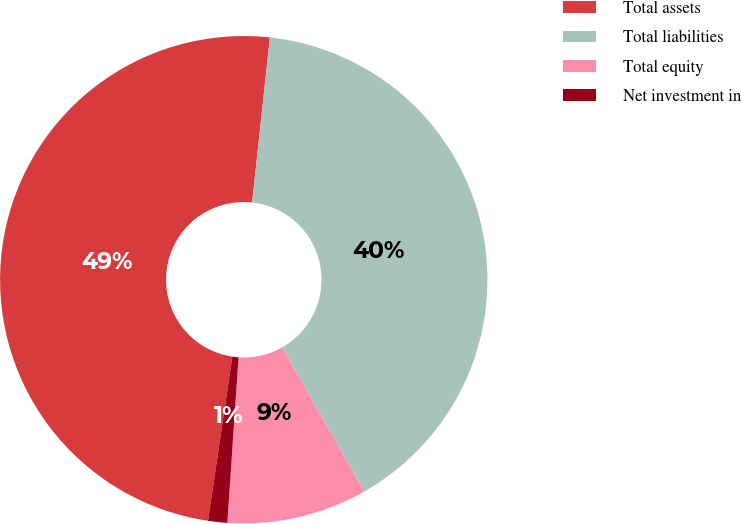Convert chart. <chart><loc_0><loc_0><loc_500><loc_500><pie_chart><fcel>Total assets<fcel>Total liabilities<fcel>Total equity<fcel>Net investment in<nl><fcel>49.36%<fcel>40.05%<fcel>9.31%<fcel>1.27%<nl></chart> 